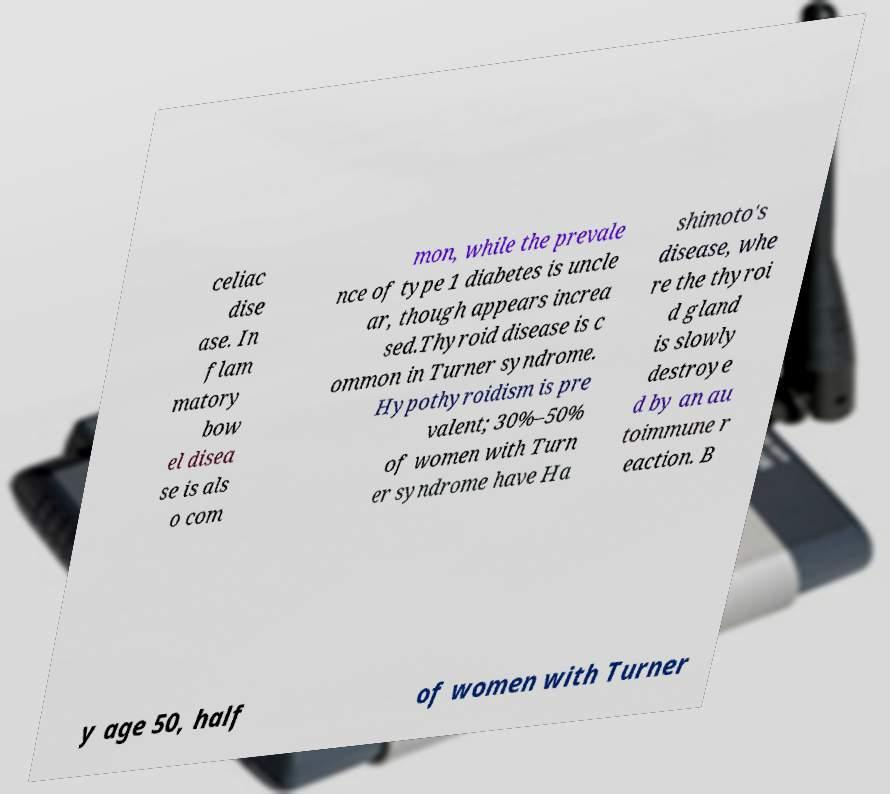Could you extract and type out the text from this image? celiac dise ase. In flam matory bow el disea se is als o com mon, while the prevale nce of type 1 diabetes is uncle ar, though appears increa sed.Thyroid disease is c ommon in Turner syndrome. Hypothyroidism is pre valent; 30%–50% of women with Turn er syndrome have Ha shimoto's disease, whe re the thyroi d gland is slowly destroye d by an au toimmune r eaction. B y age 50, half of women with Turner 